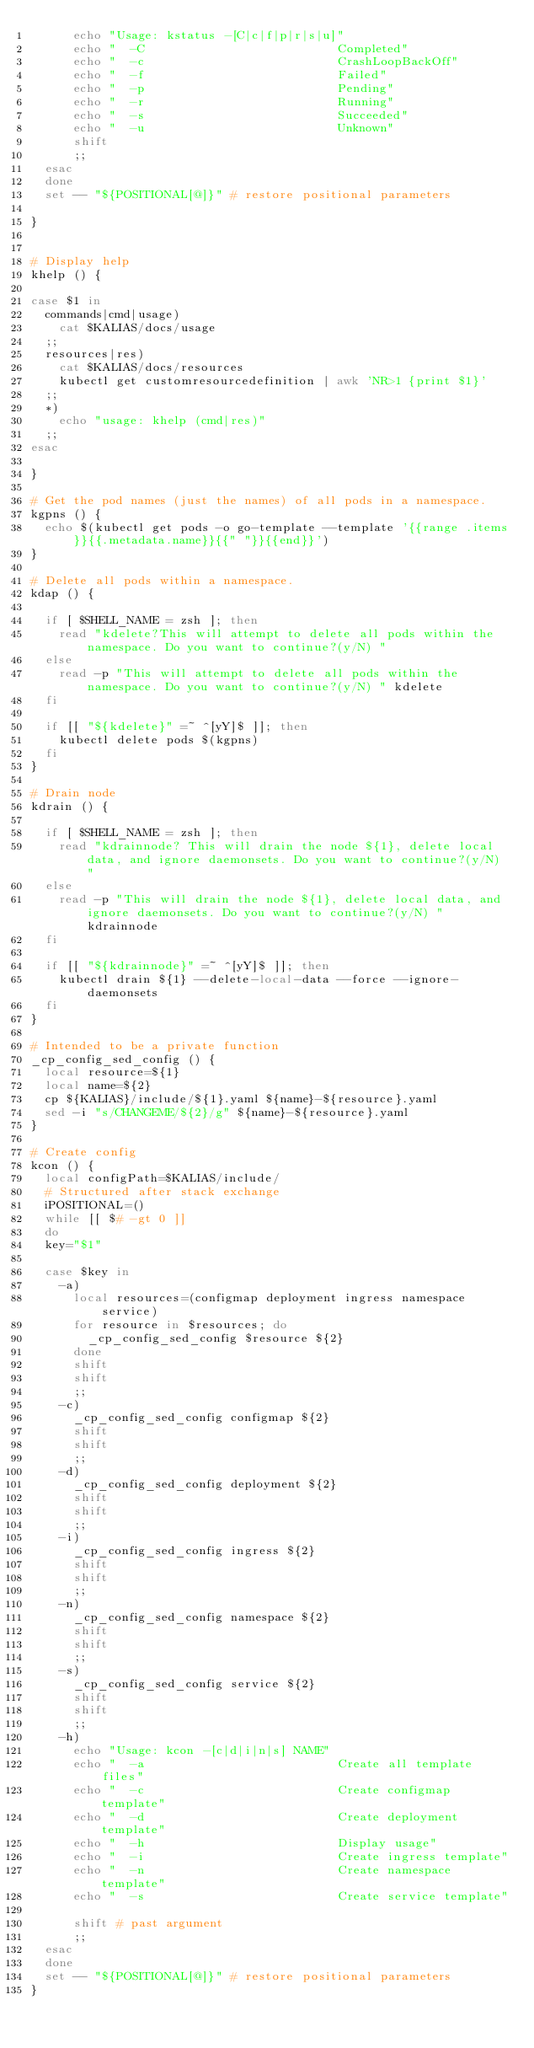<code> <loc_0><loc_0><loc_500><loc_500><_Bash_>      echo "Usage: kstatus -[C|c|f|p|r|s|u]"
      echo "  -C                           Completed"
      echo "  -c                           CrashLoopBackOff"
      echo "  -f                           Failed"
      echo "  -p                           Pending"
      echo "  -r                           Running"
      echo "  -s                           Succeeded"
      echo "  -u                           Unknown"
      shift
      ;;
  esac
  done
  set -- "${POSITIONAL[@]}" # restore positional parameters

}


# Display help
khelp () {

case $1 in
  commands|cmd|usage)
    cat $KALIAS/docs/usage
  ;;
  resources|res)
    cat $KALIAS/docs/resources
    kubectl get customresourcedefinition | awk 'NR>1 {print $1}'
  ;;
  *)
    echo "usage: khelp (cmd|res)"
  ;;
esac

}

# Get the pod names (just the names) of all pods in a namespace.
kgpns () {
  echo $(kubectl get pods -o go-template --template '{{range .items}}{{.metadata.name}}{{" "}}{{end}}')
}

# Delete all pods within a namespace.
kdap () {

  if [ $SHELL_NAME = zsh ]; then
    read "kdelete?This will attempt to delete all pods within the namespace. Do you want to continue?(y/N) "
  else
    read -p "This will attempt to delete all pods within the namespace. Do you want to continue?(y/N) " kdelete
  fi

  if [[ "${kdelete}" =~ ^[yY]$ ]]; then
    kubectl delete pods $(kgpns)
  fi
}

# Drain node
kdrain () {

  if [ $SHELL_NAME = zsh ]; then
    read "kdrainnode? This will drain the node ${1}, delete local data, and ignore daemonsets. Do you want to continue?(y/N) "
  else
    read -p "This will drain the node ${1}, delete local data, and ignore daemonsets. Do you want to continue?(y/N) " kdrainnode
  fi

  if [[ "${kdrainnode}" =~ ^[yY]$ ]]; then
    kubectl drain ${1} --delete-local-data --force --ignore-daemonsets
  fi
}

# Intended to be a private function
_cp_config_sed_config () {
  local resource=${1}
  local name=${2}
  cp ${KALIAS}/include/${1}.yaml ${name}-${resource}.yaml
  sed -i "s/CHANGEME/${2}/g" ${name}-${resource}.yaml
}

# Create config
kcon () {
  local configPath=$KALIAS/include/
  # Structured after stack exchange
  iPOSITIONAL=()
  while [[ $# -gt 0 ]]
  do
  key="$1"

  case $key in
    -a)
      local resources=(configmap deployment ingress namespace service)
      for resource in $resources; do
        _cp_config_sed_config $resource ${2}
      done
      shift
      shift
      ;;
    -c)
      _cp_config_sed_config configmap ${2}
      shift
      shift
      ;;
    -d)
      _cp_config_sed_config deployment ${2}
      shift
      shift
      ;;
    -i)
      _cp_config_sed_config ingress ${2}
      shift
      shift
      ;;
    -n)
      _cp_config_sed_config namespace ${2}
      shift
      shift
      ;;
    -s)
      _cp_config_sed_config service ${2}
      shift
      shift
      ;;
    -h)
      echo "Usage: kcon -[c|d|i|n|s] NAME"
      echo "  -a                           Create all template files"
      echo "  -c                           Create configmap template"
      echo "  -d                           Create deployment template"
      echo "  -h                           Display usage"
      echo "  -i                           Create ingress template"
      echo "  -n                           Create namespace template"
      echo "  -s                           Create service template"

      shift # past argument
      ;;
  esac
  done
  set -- "${POSITIONAL[@]}" # restore positional parameters
}
</code> 